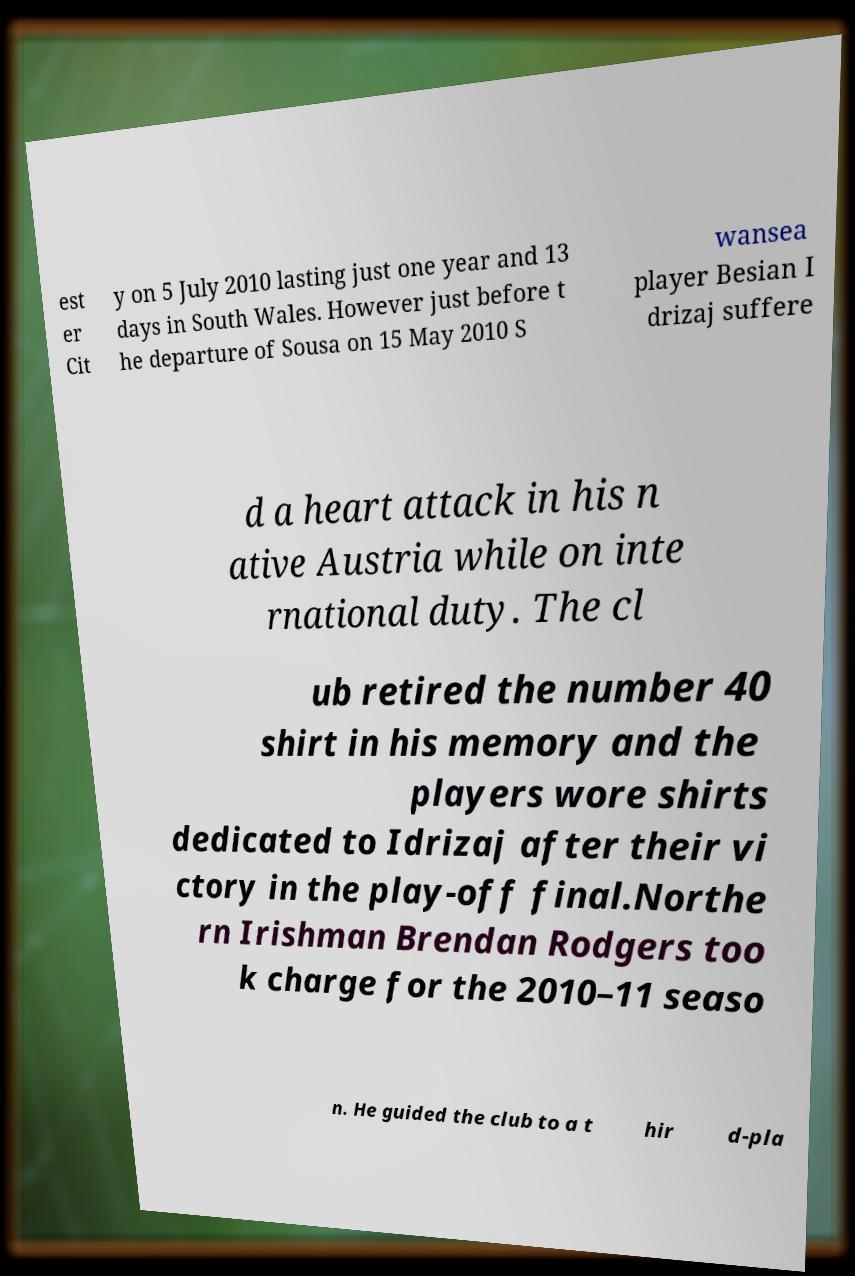Can you accurately transcribe the text from the provided image for me? est er Cit y on 5 July 2010 lasting just one year and 13 days in South Wales. However just before t he departure of Sousa on 15 May 2010 S wansea player Besian I drizaj suffere d a heart attack in his n ative Austria while on inte rnational duty. The cl ub retired the number 40 shirt in his memory and the players wore shirts dedicated to Idrizaj after their vi ctory in the play-off final.Northe rn Irishman Brendan Rodgers too k charge for the 2010–11 seaso n. He guided the club to a t hir d-pla 